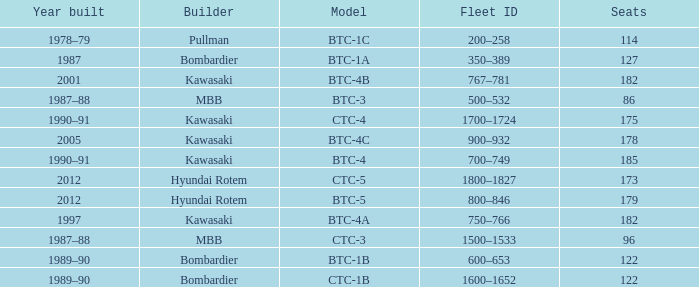How many seats does the BTC-5 model have? 179.0. 